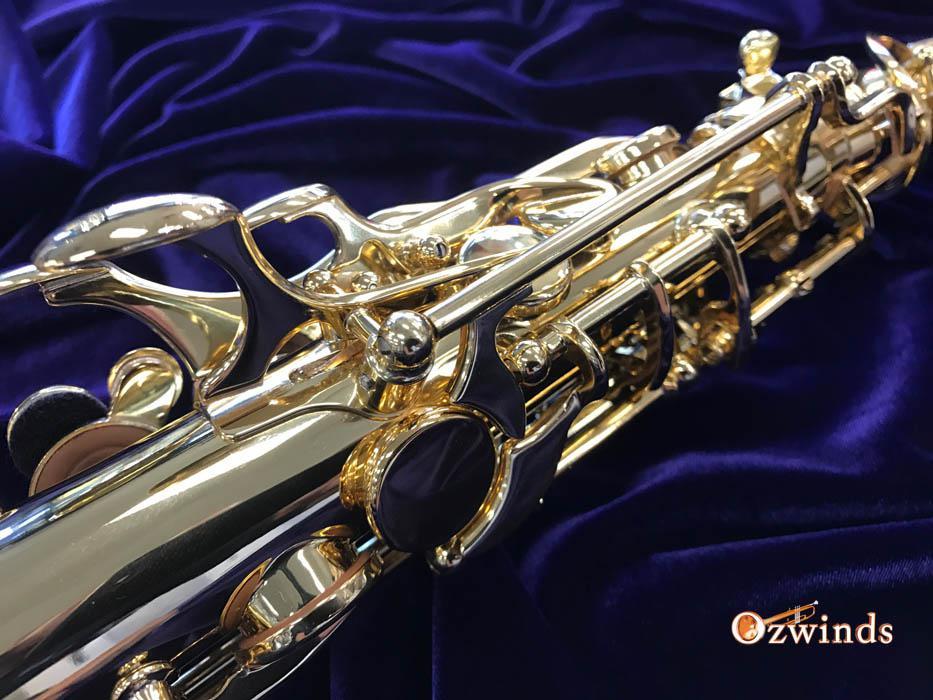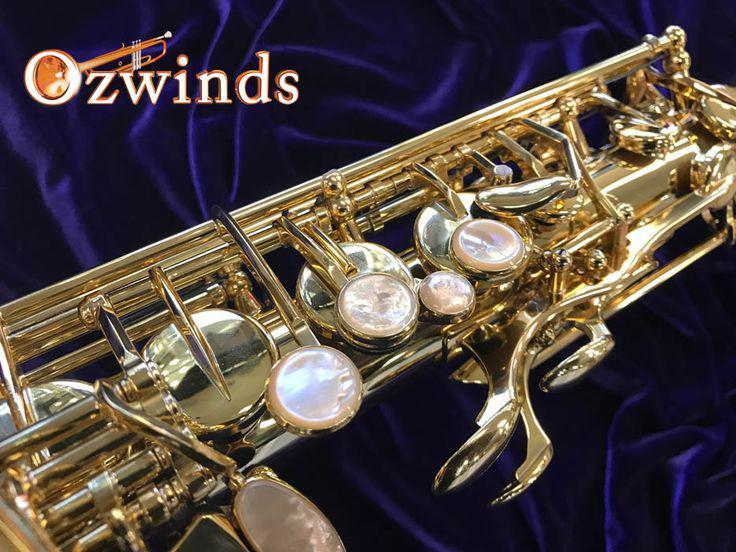The first image is the image on the left, the second image is the image on the right. For the images displayed, is the sentence "You can only see the gooseneck of one of the saxophones." factually correct? Answer yes or no. No. The first image is the image on the left, the second image is the image on the right. Given the left and right images, does the statement "Each image shows a saxophone displayed on folds of blue velvet, and in one image, the bell end of the saxophone is visible and facing upward." hold true? Answer yes or no. No. 